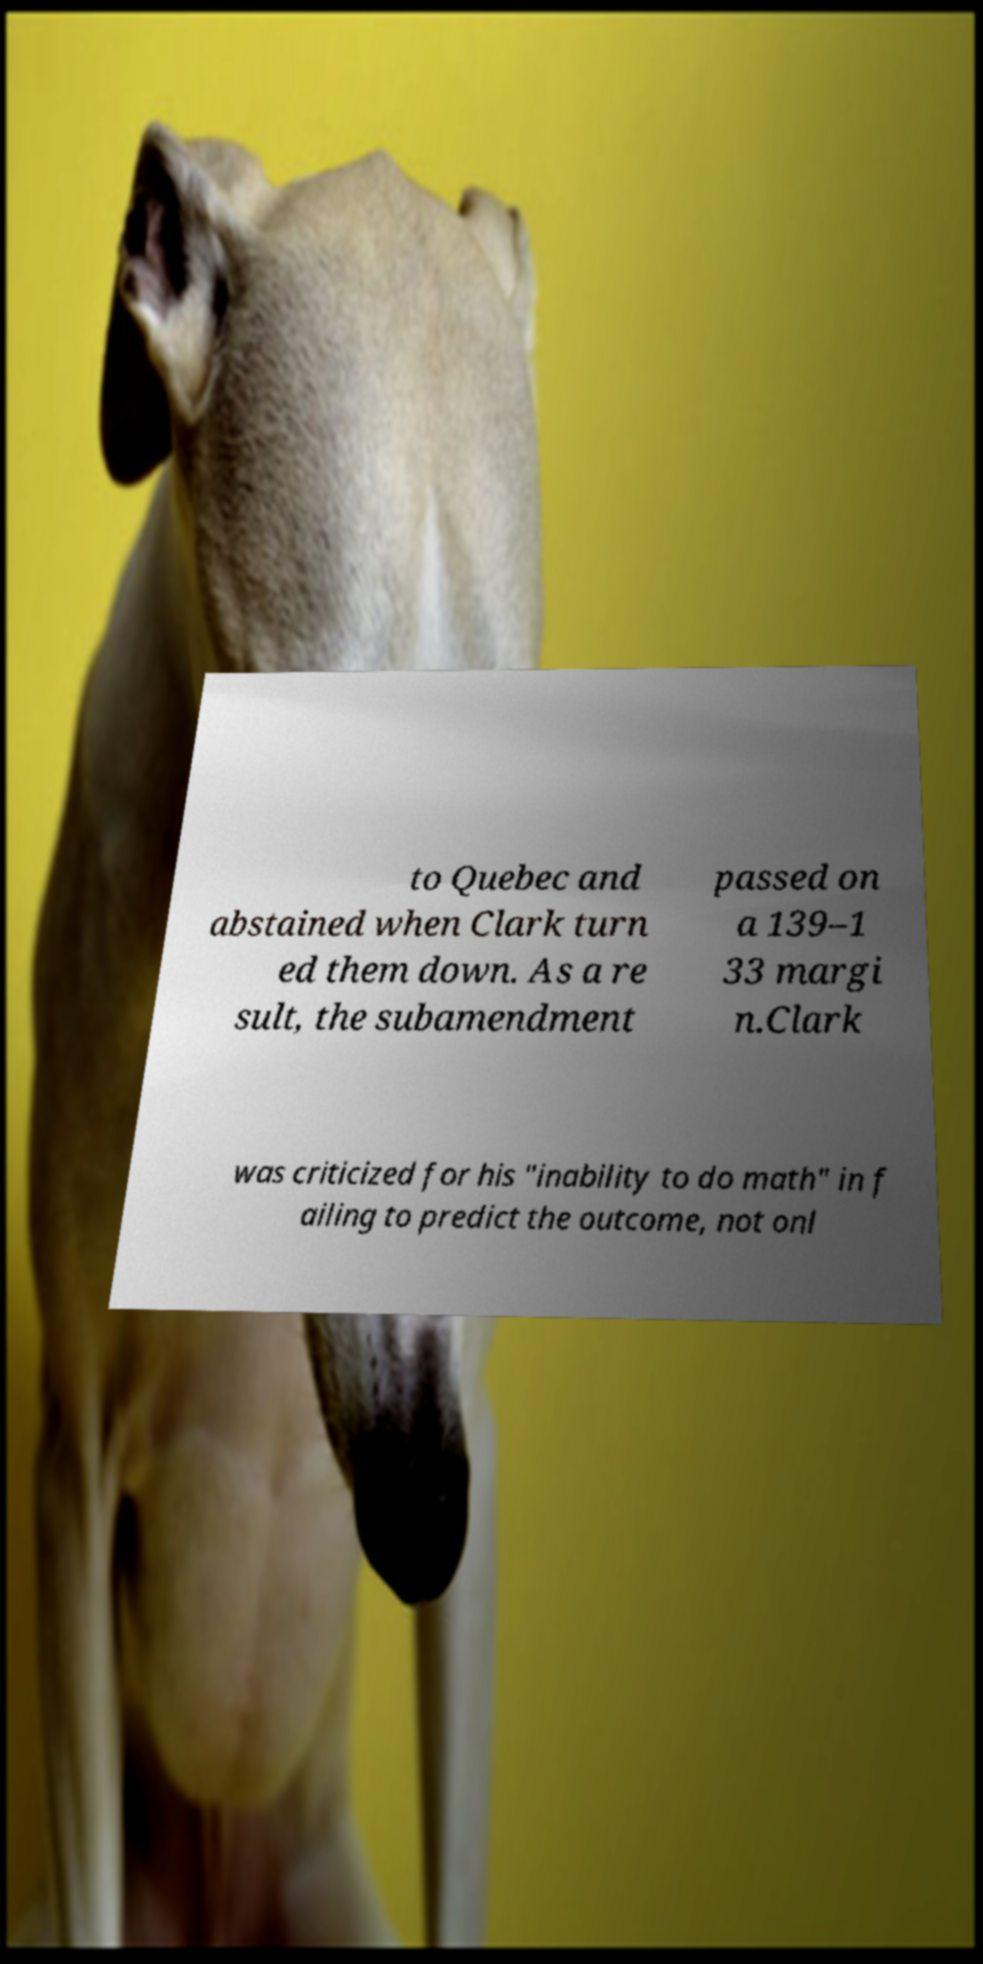I need the written content from this picture converted into text. Can you do that? to Quebec and abstained when Clark turn ed them down. As a re sult, the subamendment passed on a 139–1 33 margi n.Clark was criticized for his "inability to do math" in f ailing to predict the outcome, not onl 